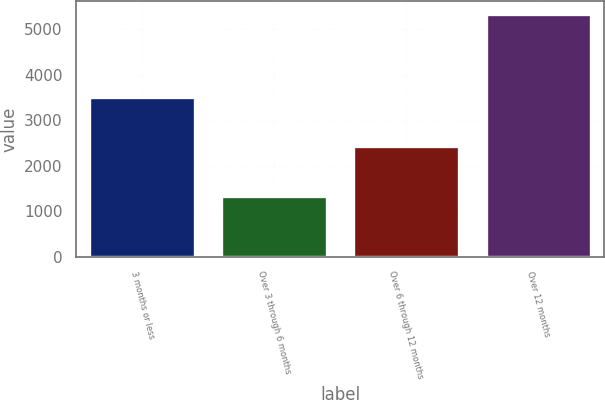Convert chart. <chart><loc_0><loc_0><loc_500><loc_500><bar_chart><fcel>3 months or less<fcel>Over 3 through 6 months<fcel>Over 6 through 12 months<fcel>Over 12 months<nl><fcel>3521<fcel>1332<fcel>2442<fcel>5349<nl></chart> 